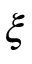<formula> <loc_0><loc_0><loc_500><loc_500>\xi</formula> 